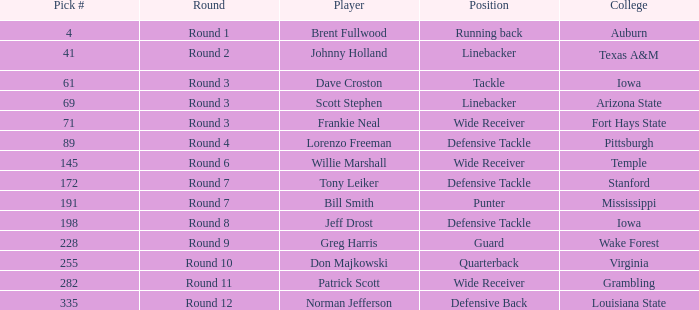What is the largest pick# for Greg Harris? 228.0. 